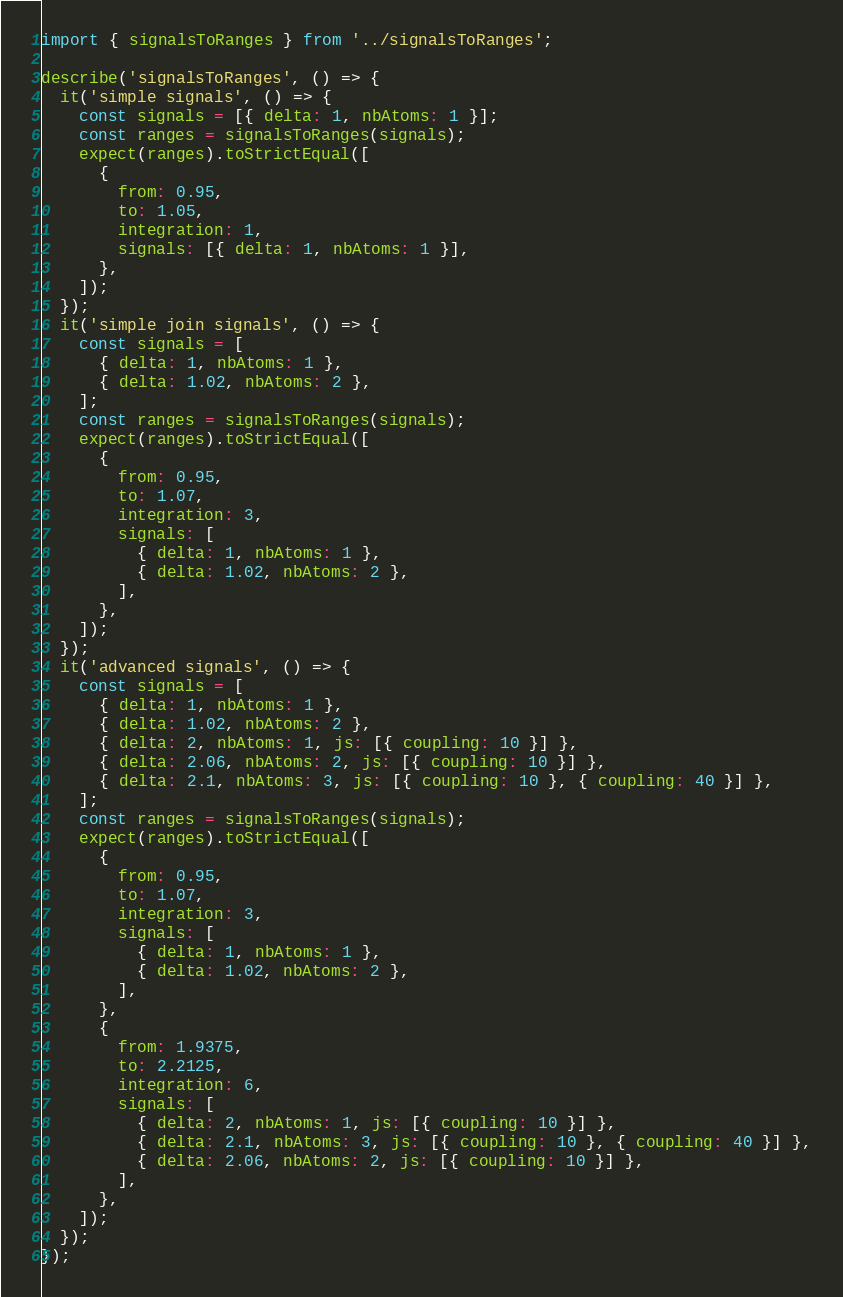<code> <loc_0><loc_0><loc_500><loc_500><_TypeScript_>import { signalsToRanges } from '../signalsToRanges';

describe('signalsToRanges', () => {
  it('simple signals', () => {
    const signals = [{ delta: 1, nbAtoms: 1 }];
    const ranges = signalsToRanges(signals);
    expect(ranges).toStrictEqual([
      {
        from: 0.95,
        to: 1.05,
        integration: 1,
        signals: [{ delta: 1, nbAtoms: 1 }],
      },
    ]);
  });
  it('simple join signals', () => {
    const signals = [
      { delta: 1, nbAtoms: 1 },
      { delta: 1.02, nbAtoms: 2 },
    ];
    const ranges = signalsToRanges(signals);
    expect(ranges).toStrictEqual([
      {
        from: 0.95,
        to: 1.07,
        integration: 3,
        signals: [
          { delta: 1, nbAtoms: 1 },
          { delta: 1.02, nbAtoms: 2 },
        ],
      },
    ]);
  });
  it('advanced signals', () => {
    const signals = [
      { delta: 1, nbAtoms: 1 },
      { delta: 1.02, nbAtoms: 2 },
      { delta: 2, nbAtoms: 1, js: [{ coupling: 10 }] },
      { delta: 2.06, nbAtoms: 2, js: [{ coupling: 10 }] },
      { delta: 2.1, nbAtoms: 3, js: [{ coupling: 10 }, { coupling: 40 }] },
    ];
    const ranges = signalsToRanges(signals);
    expect(ranges).toStrictEqual([
      {
        from: 0.95,
        to: 1.07,
        integration: 3,
        signals: [
          { delta: 1, nbAtoms: 1 },
          { delta: 1.02, nbAtoms: 2 },
        ],
      },
      {
        from: 1.9375,
        to: 2.2125,
        integration: 6,
        signals: [
          { delta: 2, nbAtoms: 1, js: [{ coupling: 10 }] },
          { delta: 2.1, nbAtoms: 3, js: [{ coupling: 10 }, { coupling: 40 }] },
          { delta: 2.06, nbAtoms: 2, js: [{ coupling: 10 }] },
        ],
      },
    ]);
  });
});
</code> 